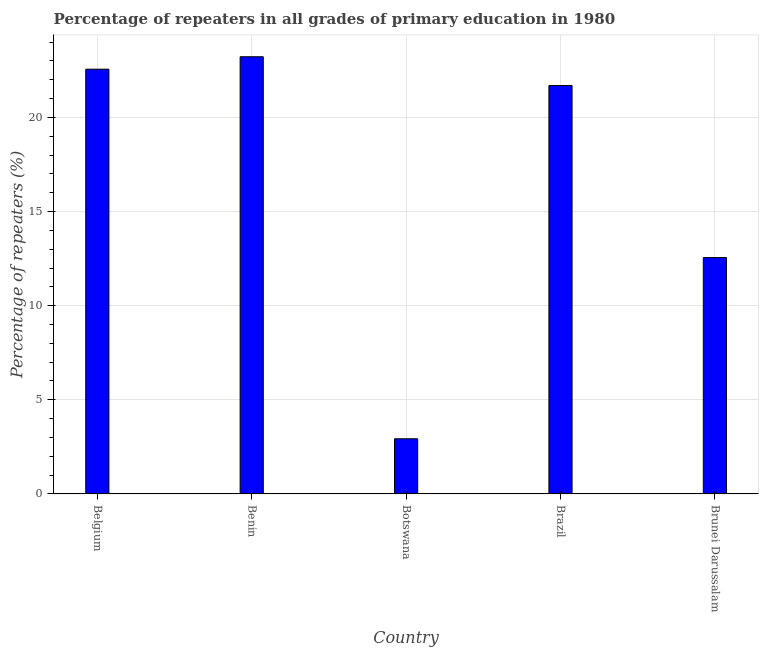Does the graph contain grids?
Ensure brevity in your answer.  Yes. What is the title of the graph?
Make the answer very short. Percentage of repeaters in all grades of primary education in 1980. What is the label or title of the X-axis?
Make the answer very short. Country. What is the label or title of the Y-axis?
Keep it short and to the point. Percentage of repeaters (%). What is the percentage of repeaters in primary education in Brunei Darussalam?
Provide a short and direct response. 12.56. Across all countries, what is the maximum percentage of repeaters in primary education?
Give a very brief answer. 23.22. Across all countries, what is the minimum percentage of repeaters in primary education?
Provide a short and direct response. 2.93. In which country was the percentage of repeaters in primary education maximum?
Keep it short and to the point. Benin. In which country was the percentage of repeaters in primary education minimum?
Keep it short and to the point. Botswana. What is the sum of the percentage of repeaters in primary education?
Ensure brevity in your answer.  82.96. What is the difference between the percentage of repeaters in primary education in Belgium and Brunei Darussalam?
Your response must be concise. 10. What is the average percentage of repeaters in primary education per country?
Offer a terse response. 16.59. What is the median percentage of repeaters in primary education?
Provide a short and direct response. 21.69. In how many countries, is the percentage of repeaters in primary education greater than 22 %?
Provide a succinct answer. 2. What is the ratio of the percentage of repeaters in primary education in Belgium to that in Brazil?
Provide a succinct answer. 1.04. Is the percentage of repeaters in primary education in Brazil less than that in Brunei Darussalam?
Offer a very short reply. No. What is the difference between the highest and the second highest percentage of repeaters in primary education?
Your response must be concise. 0.66. What is the difference between the highest and the lowest percentage of repeaters in primary education?
Ensure brevity in your answer.  20.29. In how many countries, is the percentage of repeaters in primary education greater than the average percentage of repeaters in primary education taken over all countries?
Offer a very short reply. 3. How many countries are there in the graph?
Ensure brevity in your answer.  5. Are the values on the major ticks of Y-axis written in scientific E-notation?
Provide a succinct answer. No. What is the Percentage of repeaters (%) in Belgium?
Offer a very short reply. 22.56. What is the Percentage of repeaters (%) of Benin?
Offer a terse response. 23.22. What is the Percentage of repeaters (%) in Botswana?
Offer a very short reply. 2.93. What is the Percentage of repeaters (%) of Brazil?
Your response must be concise. 21.69. What is the Percentage of repeaters (%) in Brunei Darussalam?
Keep it short and to the point. 12.56. What is the difference between the Percentage of repeaters (%) in Belgium and Benin?
Your answer should be compact. -0.66. What is the difference between the Percentage of repeaters (%) in Belgium and Botswana?
Offer a terse response. 19.63. What is the difference between the Percentage of repeaters (%) in Belgium and Brazil?
Provide a short and direct response. 0.87. What is the difference between the Percentage of repeaters (%) in Belgium and Brunei Darussalam?
Make the answer very short. 10. What is the difference between the Percentage of repeaters (%) in Benin and Botswana?
Keep it short and to the point. 20.29. What is the difference between the Percentage of repeaters (%) in Benin and Brazil?
Provide a short and direct response. 1.53. What is the difference between the Percentage of repeaters (%) in Benin and Brunei Darussalam?
Offer a terse response. 10.67. What is the difference between the Percentage of repeaters (%) in Botswana and Brazil?
Provide a short and direct response. -18.76. What is the difference between the Percentage of repeaters (%) in Botswana and Brunei Darussalam?
Your answer should be compact. -9.62. What is the difference between the Percentage of repeaters (%) in Brazil and Brunei Darussalam?
Make the answer very short. 9.14. What is the ratio of the Percentage of repeaters (%) in Belgium to that in Botswana?
Keep it short and to the point. 7.7. What is the ratio of the Percentage of repeaters (%) in Belgium to that in Brunei Darussalam?
Ensure brevity in your answer.  1.8. What is the ratio of the Percentage of repeaters (%) in Benin to that in Botswana?
Offer a terse response. 7.92. What is the ratio of the Percentage of repeaters (%) in Benin to that in Brazil?
Give a very brief answer. 1.07. What is the ratio of the Percentage of repeaters (%) in Benin to that in Brunei Darussalam?
Make the answer very short. 1.85. What is the ratio of the Percentage of repeaters (%) in Botswana to that in Brazil?
Offer a very short reply. 0.14. What is the ratio of the Percentage of repeaters (%) in Botswana to that in Brunei Darussalam?
Offer a terse response. 0.23. What is the ratio of the Percentage of repeaters (%) in Brazil to that in Brunei Darussalam?
Make the answer very short. 1.73. 